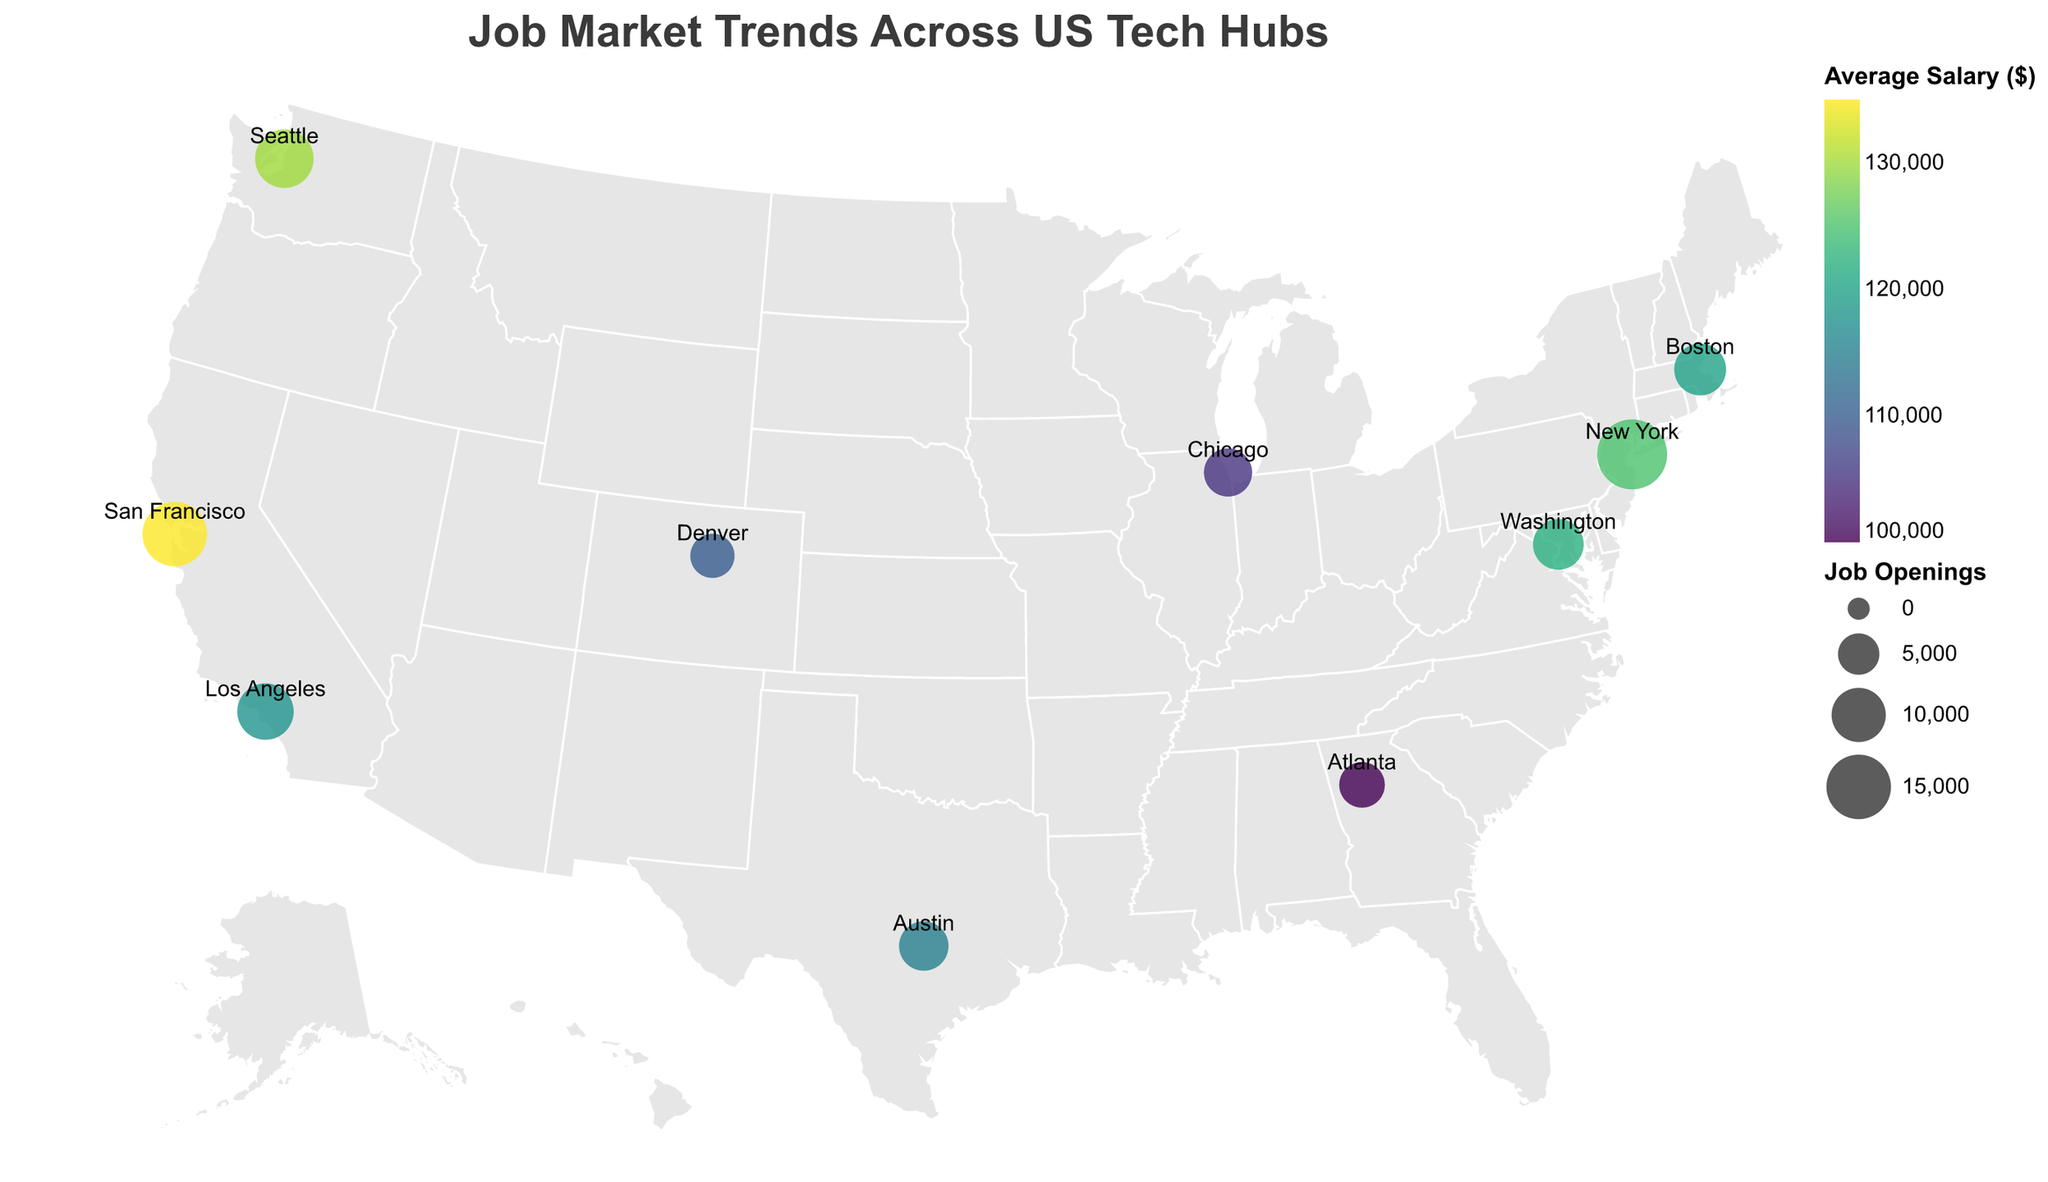What city has the highest average salary? Look at the color legend, the color with the highest value represents the city with the highest average salary. San Francisco has the highest average salary at $135,000.
Answer: San Francisco Which city has more job openings, New York or Seattle? Compare the sizes of the circles for New York and Seattle. New York has 18,000 job openings, and Seattle has 12,000 job openings.
Answer: New York What is the job security index for Austin, Texas? Hover over the circle representing Austin, Texas to reveal the tooltip. The job security index shown is 7.8.
Answer: 7.8 Which city has the smallest number of job openings? Compare the sizes of the circles for all cities. Denver has the smallest circle with 6,000 job openings.
Answer: Denver Among the cities listed, which one has the lowest average salary? Look at the color legend, the color with the lowest value represents the city with the lowest average salary. Atlanta has the lowest average salary at $100,000.
Answer: Atlanta How does the job security index of Washington, DC compare to that of San Francisco? Compare the job security index values from the tooltip for both cities. Washington, DC has a job security index of 7.9, which is higher than San Francisco's 7.5.
Answer: Washington, DC has a higher job security index Which city is closest in average salary to Los Angeles? Compare the average salary values given in the color legend. Boston's average salary is $120,000 which is closest to Los Angeles's $118,000.
Answer: Boston If you were concerned about job security, which city would you consider moving to? Look for cities with the highest job security index. Seattle has the highest job security index at 8.0.
Answer: Seattle 